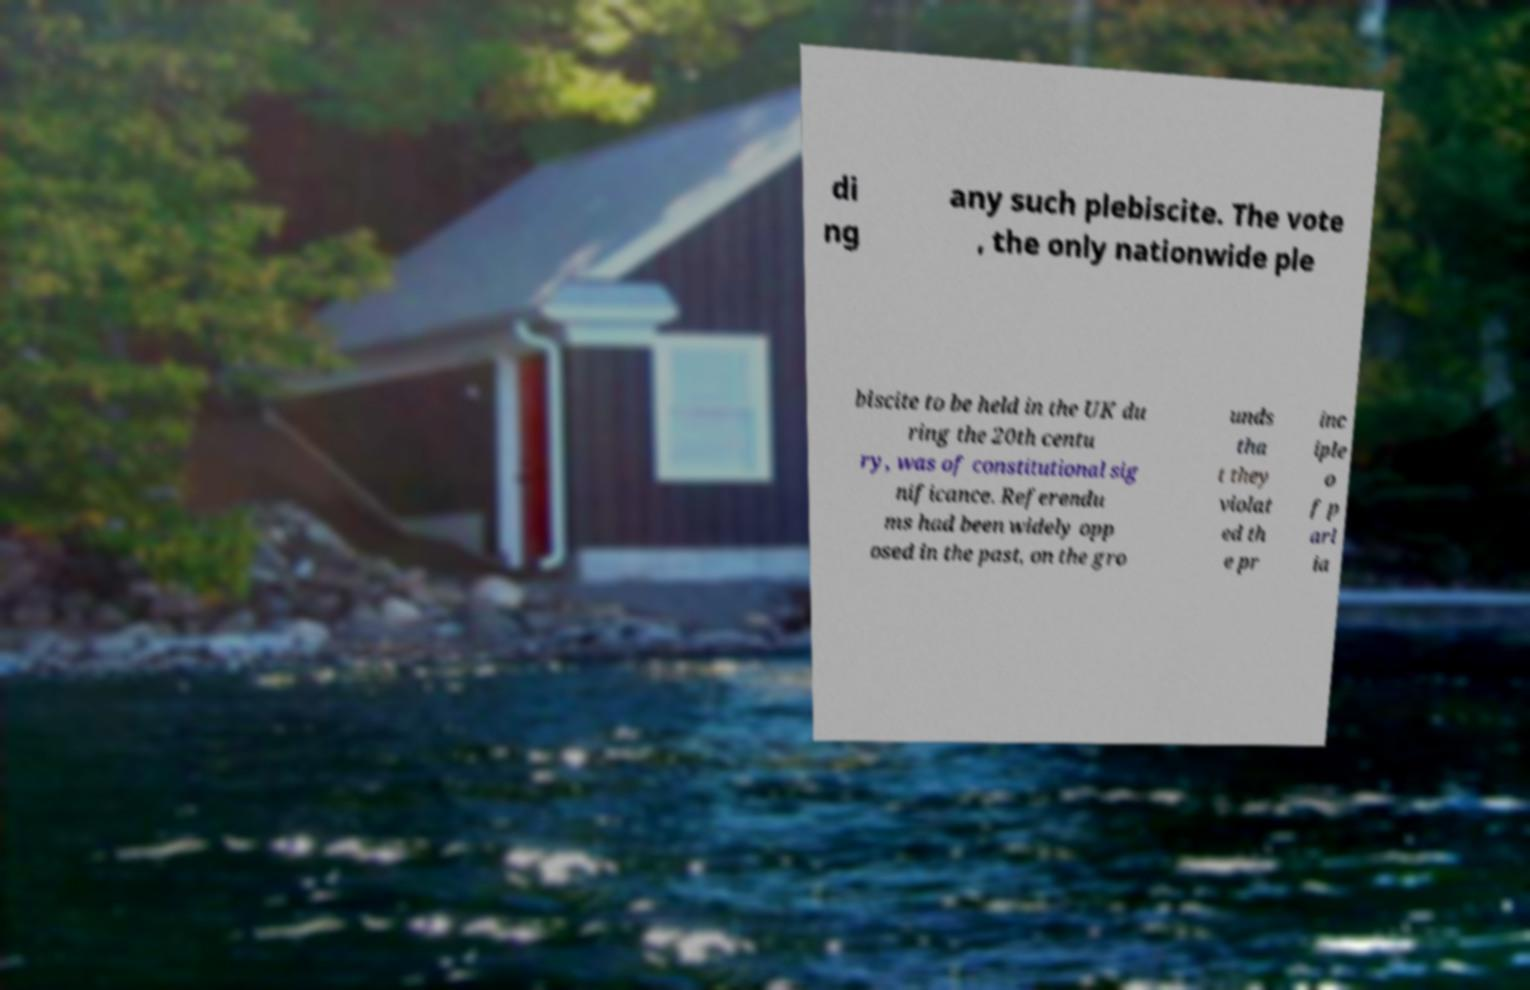For documentation purposes, I need the text within this image transcribed. Could you provide that? di ng any such plebiscite. The vote , the only nationwide ple biscite to be held in the UK du ring the 20th centu ry, was of constitutional sig nificance. Referendu ms had been widely opp osed in the past, on the gro unds tha t they violat ed th e pr inc iple o f p arl ia 